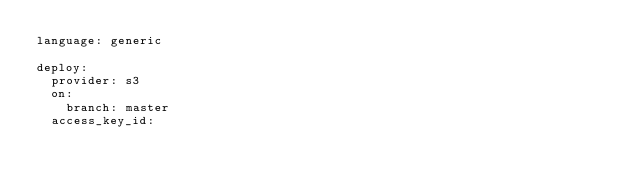Convert code to text. <code><loc_0><loc_0><loc_500><loc_500><_YAML_>language: generic

deploy:
  provider: s3
  on:
    branch: master
  access_key_id:</code> 